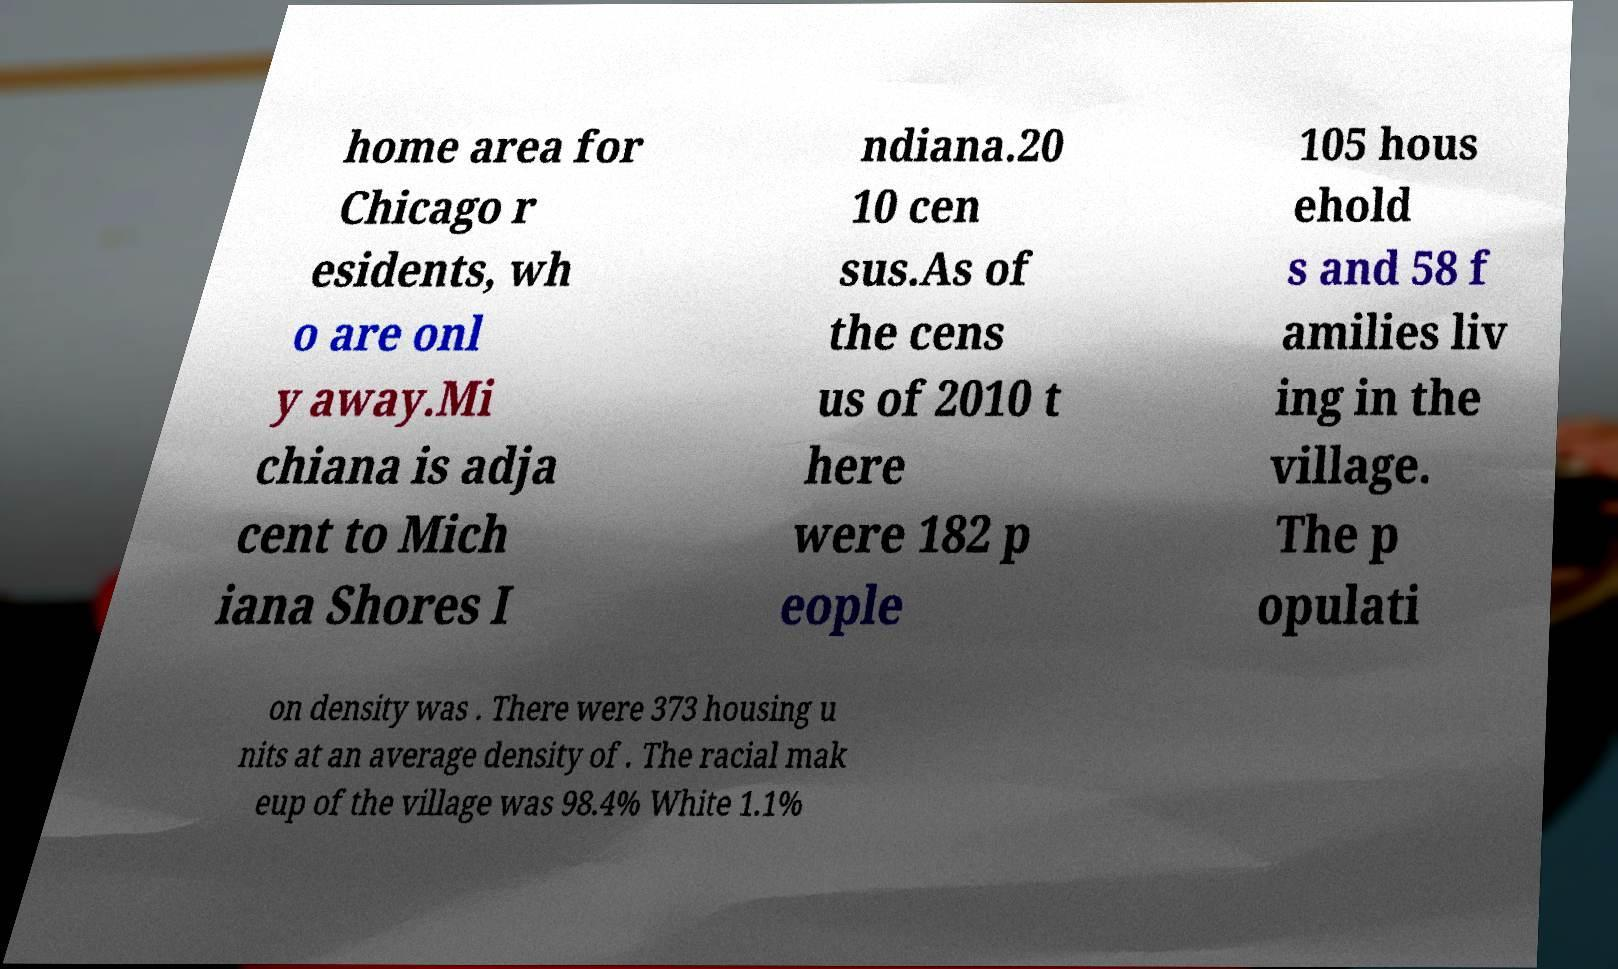Could you assist in decoding the text presented in this image and type it out clearly? home area for Chicago r esidents, wh o are onl y away.Mi chiana is adja cent to Mich iana Shores I ndiana.20 10 cen sus.As of the cens us of 2010 t here were 182 p eople 105 hous ehold s and 58 f amilies liv ing in the village. The p opulati on density was . There were 373 housing u nits at an average density of . The racial mak eup of the village was 98.4% White 1.1% 